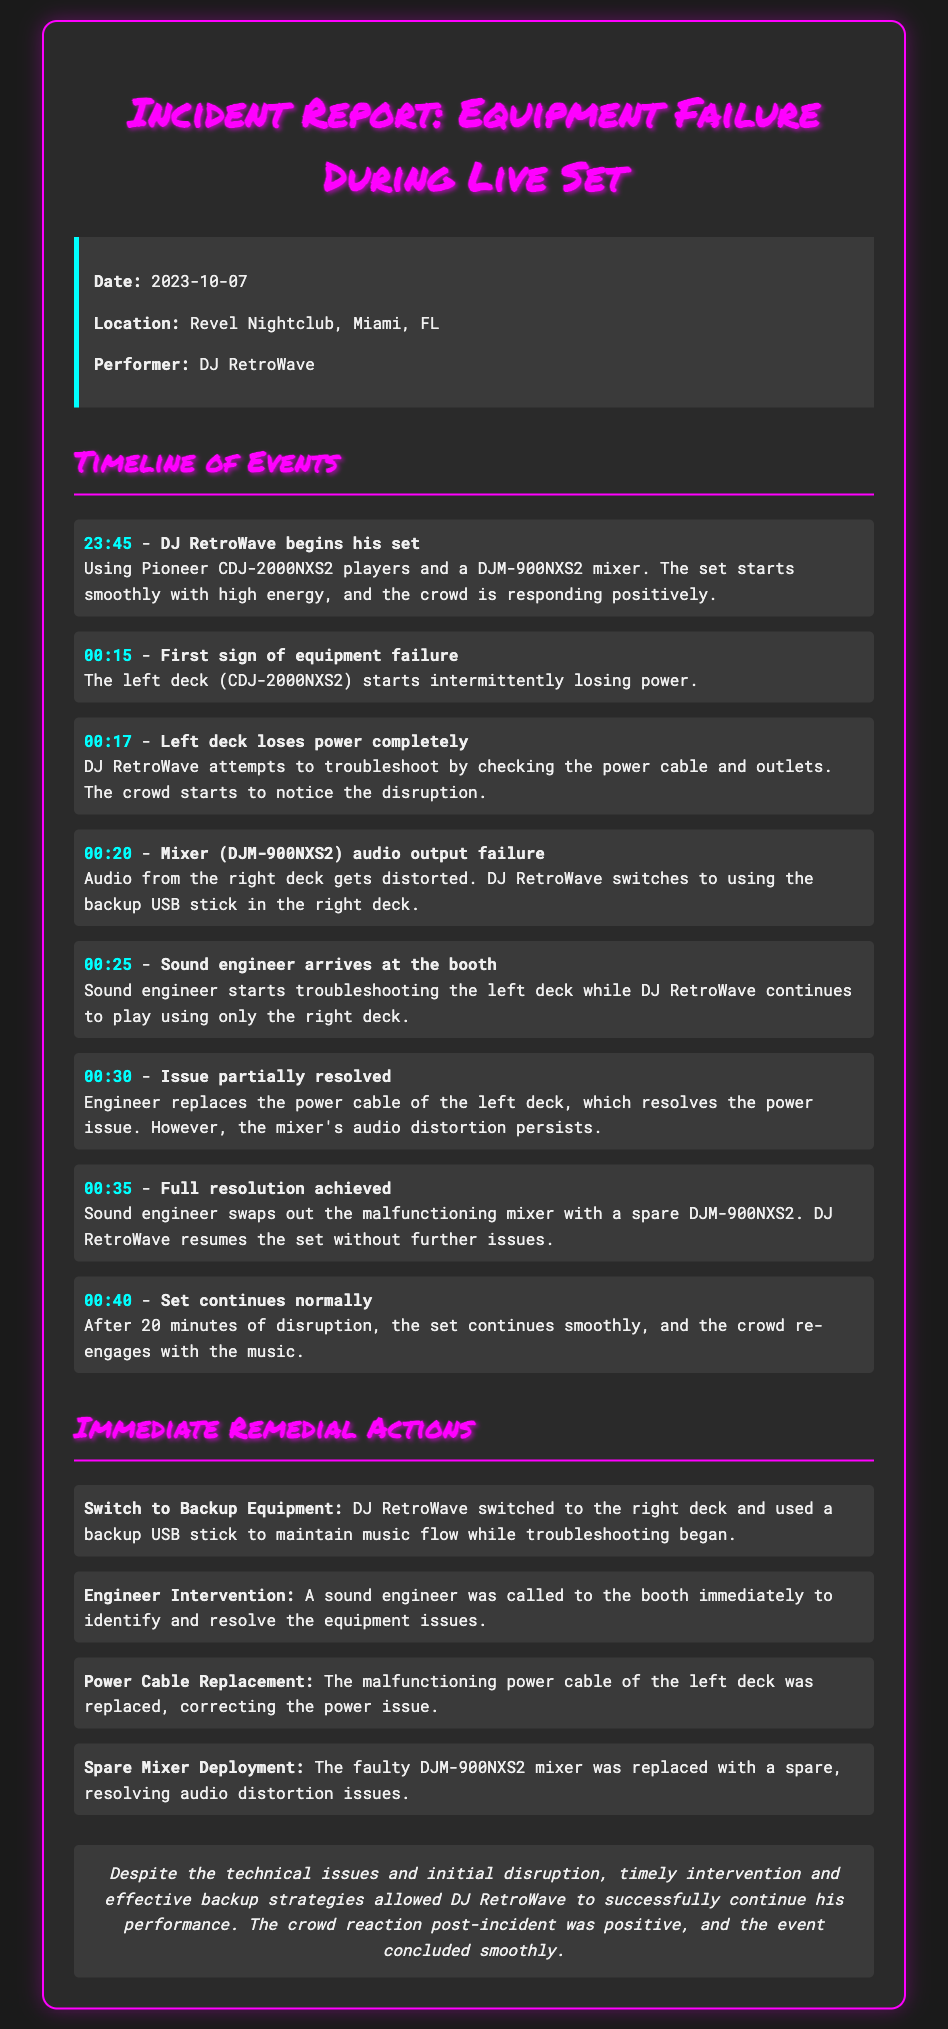What was the date of the incident? The date of the incident is stated in the document.
Answer: 2023-10-07 Who was the performer? The document specifies the name of the performer.
Answer: DJ RetroWave What equipment was used for the left deck? The document mentions the specific model of the left deck.
Answer: CDJ-2000NXS2 At what time did the mixer audio output fail? The timeline provides the exact time for this event.
Answer: 00:20 What immediate action was taken to address the power issue? The document details the remedial actions taken during the incident.
Answer: Power Cable Replacement How long did the disruption last? The timeline reflects the duration of the disruption.
Answer: 20 minutes What type of mixer was replaced during the incident? The document identifies the specific model of the mixer that was replaced.
Answer: DJM-900NXS2 What was the crowd's reaction after the incident? The document concludes by mentioning the crowd's response after the issues were resolved.
Answer: Positive 